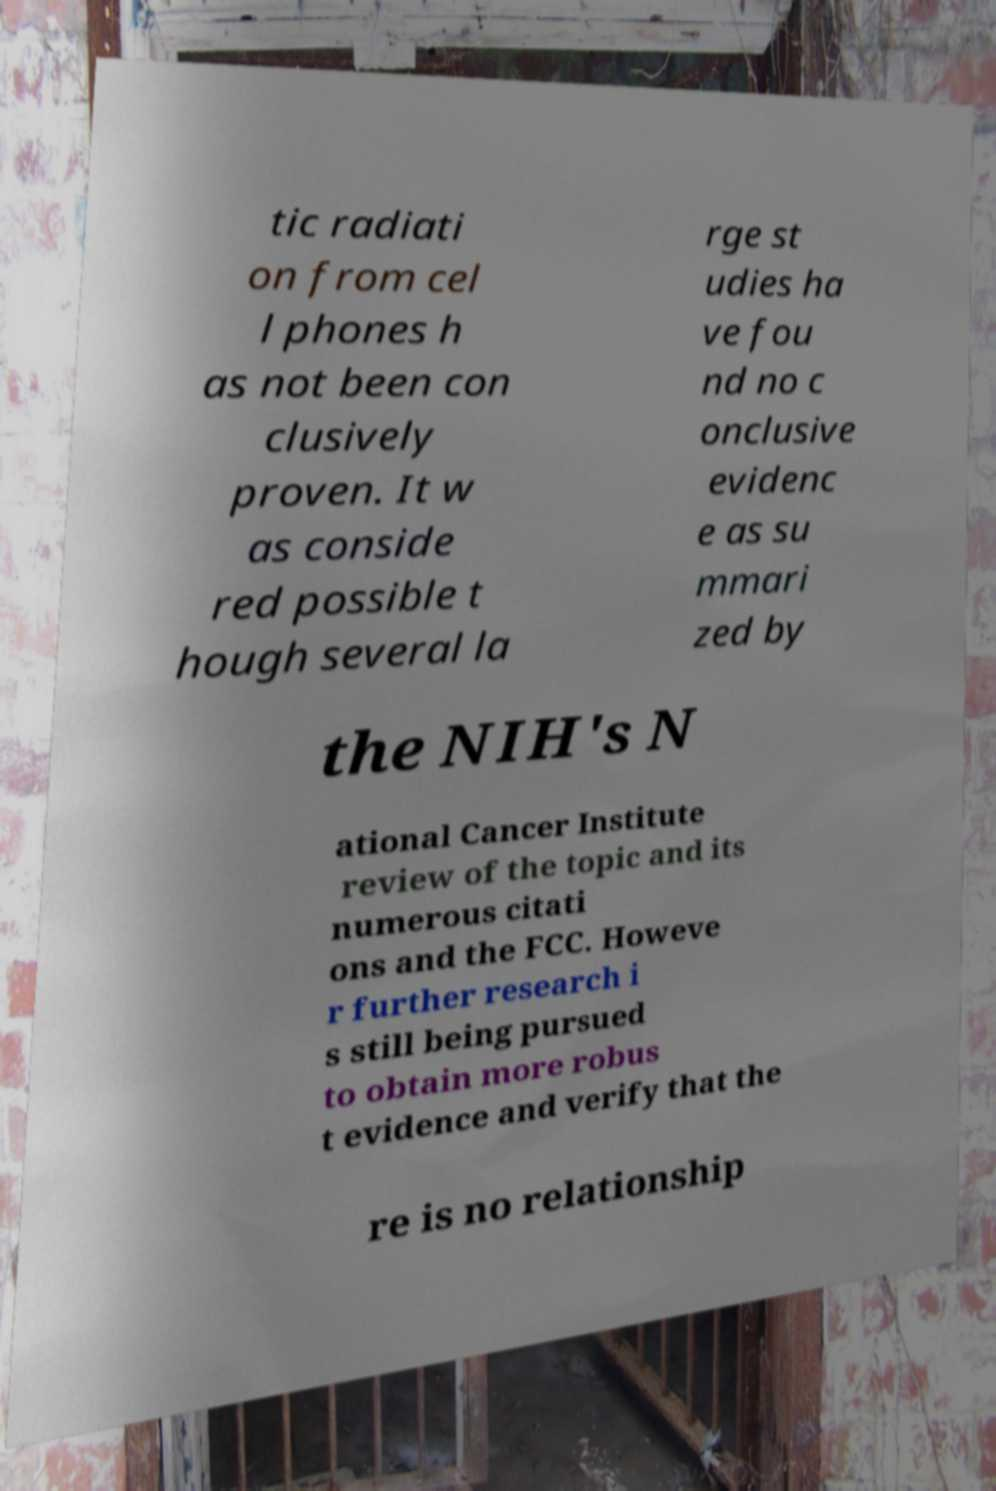Please read and relay the text visible in this image. What does it say? tic radiati on from cel l phones h as not been con clusively proven. It w as conside red possible t hough several la rge st udies ha ve fou nd no c onclusive evidenc e as su mmari zed by the NIH's N ational Cancer Institute review of the topic and its numerous citati ons and the FCC. Howeve r further research i s still being pursued to obtain more robus t evidence and verify that the re is no relationship 